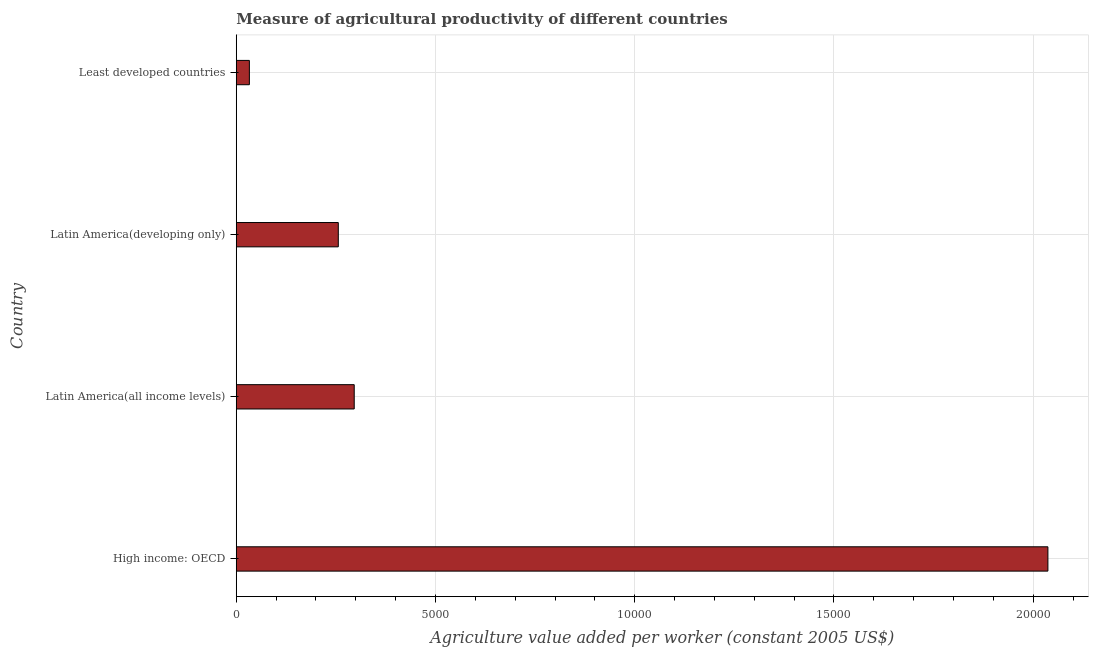Does the graph contain any zero values?
Offer a very short reply. No. What is the title of the graph?
Give a very brief answer. Measure of agricultural productivity of different countries. What is the label or title of the X-axis?
Your answer should be very brief. Agriculture value added per worker (constant 2005 US$). What is the label or title of the Y-axis?
Your answer should be compact. Country. What is the agriculture value added per worker in Latin America(developing only)?
Make the answer very short. 2560.89. Across all countries, what is the maximum agriculture value added per worker?
Offer a terse response. 2.04e+04. Across all countries, what is the minimum agriculture value added per worker?
Provide a short and direct response. 329.39. In which country was the agriculture value added per worker maximum?
Offer a terse response. High income: OECD. In which country was the agriculture value added per worker minimum?
Your answer should be compact. Least developed countries. What is the sum of the agriculture value added per worker?
Keep it short and to the point. 2.62e+04. What is the difference between the agriculture value added per worker in High income: OECD and Least developed countries?
Make the answer very short. 2.00e+04. What is the average agriculture value added per worker per country?
Give a very brief answer. 6554.99. What is the median agriculture value added per worker?
Your answer should be very brief. 2760.72. In how many countries, is the agriculture value added per worker greater than 8000 US$?
Your response must be concise. 1. What is the ratio of the agriculture value added per worker in High income: OECD to that in Latin America(developing only)?
Your answer should be compact. 7.95. Is the agriculture value added per worker in Latin America(all income levels) less than that in Latin America(developing only)?
Ensure brevity in your answer.  No. What is the difference between the highest and the second highest agriculture value added per worker?
Your answer should be very brief. 1.74e+04. What is the difference between the highest and the lowest agriculture value added per worker?
Give a very brief answer. 2.00e+04. How many bars are there?
Provide a succinct answer. 4. Are all the bars in the graph horizontal?
Your answer should be compact. Yes. How many countries are there in the graph?
Offer a very short reply. 4. What is the Agriculture value added per worker (constant 2005 US$) in High income: OECD?
Give a very brief answer. 2.04e+04. What is the Agriculture value added per worker (constant 2005 US$) of Latin America(all income levels)?
Provide a succinct answer. 2960.56. What is the Agriculture value added per worker (constant 2005 US$) of Latin America(developing only)?
Provide a succinct answer. 2560.89. What is the Agriculture value added per worker (constant 2005 US$) of Least developed countries?
Your answer should be very brief. 329.39. What is the difference between the Agriculture value added per worker (constant 2005 US$) in High income: OECD and Latin America(all income levels)?
Your answer should be very brief. 1.74e+04. What is the difference between the Agriculture value added per worker (constant 2005 US$) in High income: OECD and Latin America(developing only)?
Offer a very short reply. 1.78e+04. What is the difference between the Agriculture value added per worker (constant 2005 US$) in High income: OECD and Least developed countries?
Your response must be concise. 2.00e+04. What is the difference between the Agriculture value added per worker (constant 2005 US$) in Latin America(all income levels) and Latin America(developing only)?
Your answer should be very brief. 399.67. What is the difference between the Agriculture value added per worker (constant 2005 US$) in Latin America(all income levels) and Least developed countries?
Make the answer very short. 2631.17. What is the difference between the Agriculture value added per worker (constant 2005 US$) in Latin America(developing only) and Least developed countries?
Offer a terse response. 2231.49. What is the ratio of the Agriculture value added per worker (constant 2005 US$) in High income: OECD to that in Latin America(all income levels)?
Provide a short and direct response. 6.88. What is the ratio of the Agriculture value added per worker (constant 2005 US$) in High income: OECD to that in Latin America(developing only)?
Provide a short and direct response. 7.95. What is the ratio of the Agriculture value added per worker (constant 2005 US$) in High income: OECD to that in Least developed countries?
Your response must be concise. 61.84. What is the ratio of the Agriculture value added per worker (constant 2005 US$) in Latin America(all income levels) to that in Latin America(developing only)?
Your answer should be very brief. 1.16. What is the ratio of the Agriculture value added per worker (constant 2005 US$) in Latin America(all income levels) to that in Least developed countries?
Make the answer very short. 8.99. What is the ratio of the Agriculture value added per worker (constant 2005 US$) in Latin America(developing only) to that in Least developed countries?
Give a very brief answer. 7.78. 